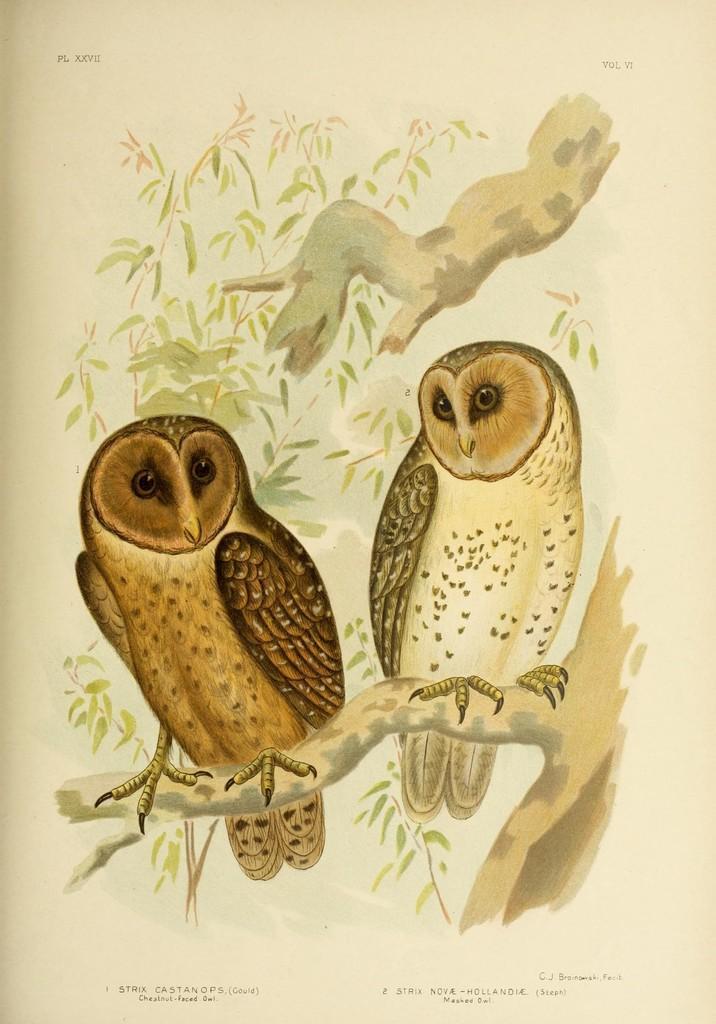How would you summarize this image in a sentence or two? This picture might be a painting on the paper. In this image, we can see two owls are holding a tree a trunk. In the background, we can also see some trees. 